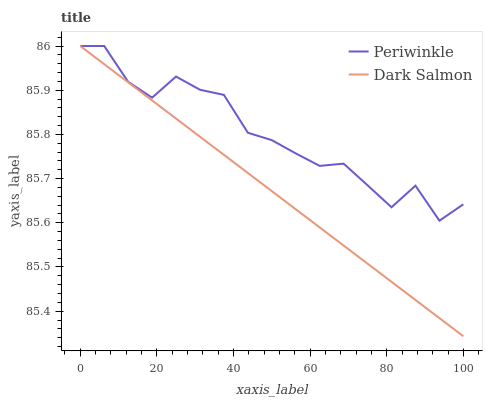Does Dark Salmon have the maximum area under the curve?
Answer yes or no. No. Is Dark Salmon the roughest?
Answer yes or no. No. 